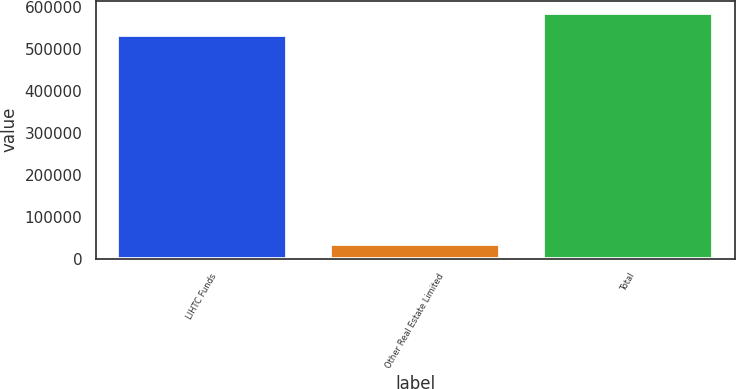<chart> <loc_0><loc_0><loc_500><loc_500><bar_chart><fcel>LIHTC Funds<fcel>Other Real Estate Limited<fcel>Total<nl><fcel>533311<fcel>35467<fcel>586642<nl></chart> 